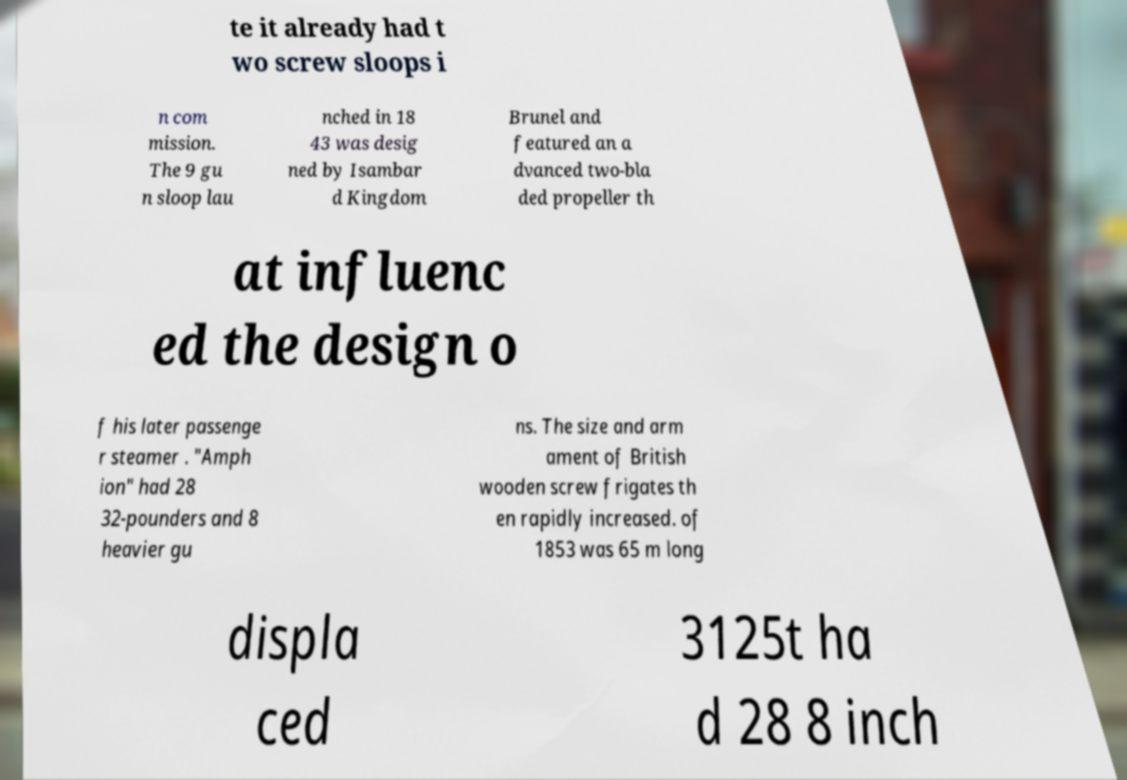Can you read and provide the text displayed in the image?This photo seems to have some interesting text. Can you extract and type it out for me? te it already had t wo screw sloops i n com mission. The 9 gu n sloop lau nched in 18 43 was desig ned by Isambar d Kingdom Brunel and featured an a dvanced two-bla ded propeller th at influenc ed the design o f his later passenge r steamer . "Amph ion" had 28 32-pounders and 8 heavier gu ns. The size and arm ament of British wooden screw frigates th en rapidly increased. of 1853 was 65 m long displa ced 3125t ha d 28 8 inch 